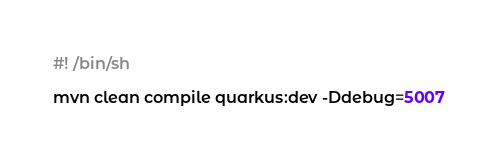Convert code to text. <code><loc_0><loc_0><loc_500><loc_500><_Bash_>#! /bin/sh 

mvn clean compile quarkus:dev -Ddebug=5007

</code> 